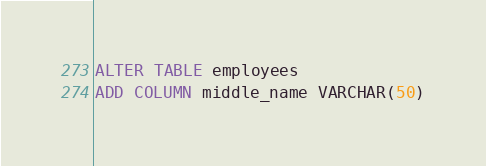Convert code to text. <code><loc_0><loc_0><loc_500><loc_500><_SQL_>ALTER TABLE employees
ADD COLUMN middle_name VARCHAR(50)</code> 